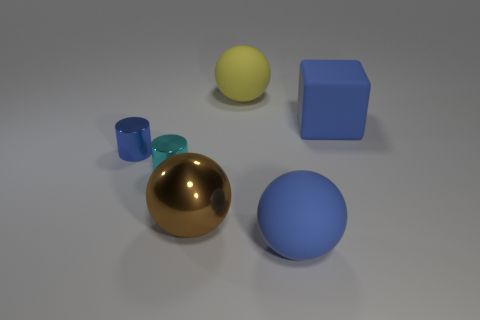Is there any other thing that has the same size as the blue shiny cylinder?
Make the answer very short. Yes. The matte thing on the right side of the matte object that is in front of the ball that is to the left of the large yellow rubber sphere is what shape?
Give a very brief answer. Cube. What number of things are either blue things that are in front of the small cyan metallic cylinder or big things that are on the right side of the big brown metal ball?
Ensure brevity in your answer.  3. There is a yellow matte object; does it have the same size as the blue matte thing behind the blue shiny cylinder?
Give a very brief answer. Yes. Is the sphere in front of the large shiny thing made of the same material as the big blue thing behind the blue sphere?
Provide a short and direct response. Yes. Are there an equal number of cyan things that are behind the tiny blue metal object and big brown balls that are right of the large brown object?
Make the answer very short. Yes. What number of big metallic objects have the same color as the big metal ball?
Ensure brevity in your answer.  0. What material is the big sphere that is the same color as the large block?
Make the answer very short. Rubber. How many shiny objects are blue cubes or cylinders?
Offer a terse response. 2. Does the big blue matte object in front of the tiny blue thing have the same shape as the blue rubber object that is behind the blue rubber ball?
Your answer should be compact. No. 